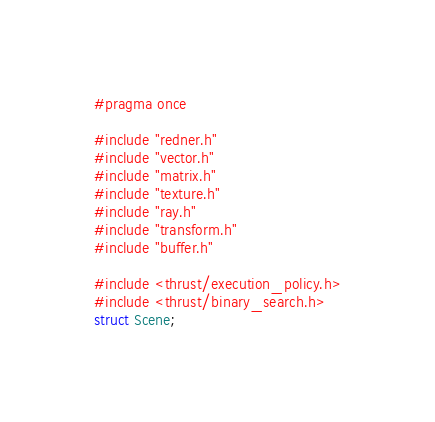<code> <loc_0><loc_0><loc_500><loc_500><_C_>#pragma once

#include "redner.h"
#include "vector.h"
#include "matrix.h"
#include "texture.h"
#include "ray.h"
#include "transform.h"
#include "buffer.h"

#include <thrust/execution_policy.h>
#include <thrust/binary_search.h>
struct Scene;
</code> 